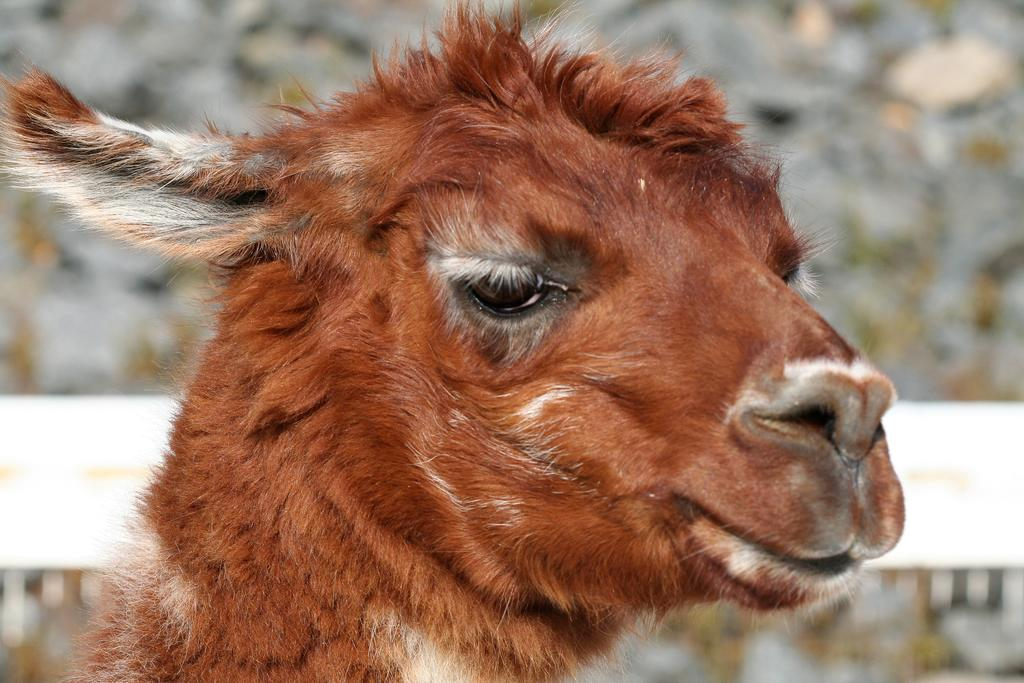What type of creature is in the image? There is an animal in the image. Can you describe the color pattern of the animal? The animal is brown and white in color. How is the animal positioned in the image? The animal is blurred in the background. What type of wax can be seen melting in the image? There is no wax present in the image; it features an animal that is brown and white in color and blurred in the background. 